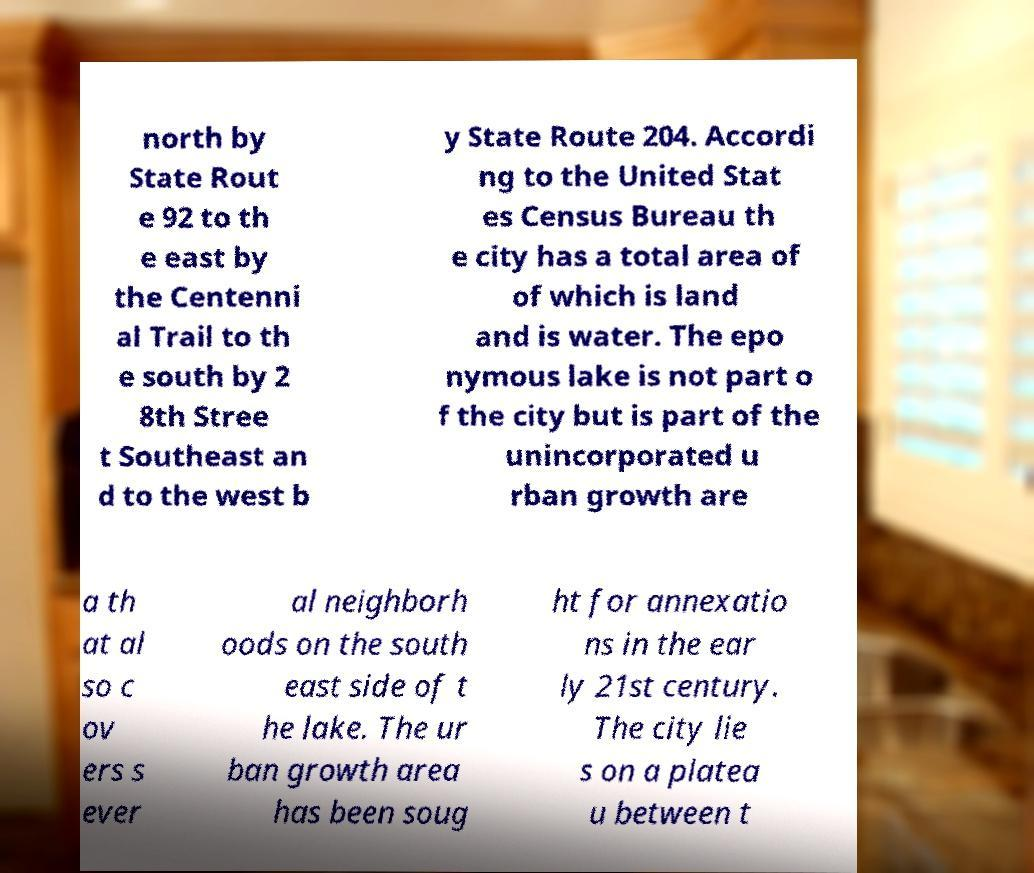Please read and relay the text visible in this image. What does it say? north by State Rout e 92 to th e east by the Centenni al Trail to th e south by 2 8th Stree t Southeast an d to the west b y State Route 204. Accordi ng to the United Stat es Census Bureau th e city has a total area of of which is land and is water. The epo nymous lake is not part o f the city but is part of the unincorporated u rban growth are a th at al so c ov ers s ever al neighborh oods on the south east side of t he lake. The ur ban growth area has been soug ht for annexatio ns in the ear ly 21st century. The city lie s on a platea u between t 